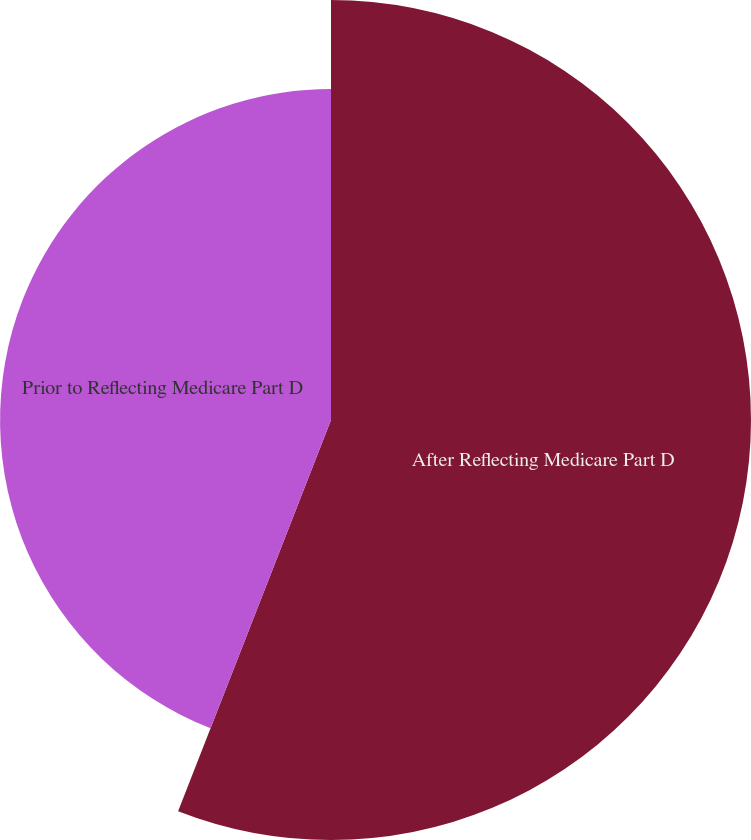<chart> <loc_0><loc_0><loc_500><loc_500><pie_chart><fcel>After Reflecting Medicare Part D<fcel>Prior to Reflecting Medicare Part D<nl><fcel>55.93%<fcel>44.07%<nl></chart> 